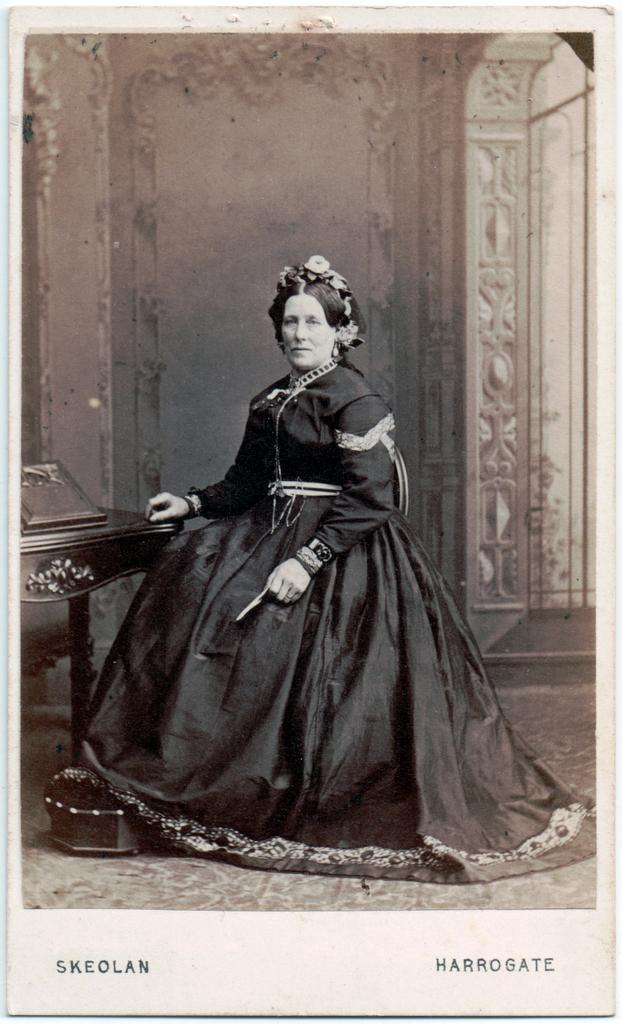Could you give a brief overview of what you see in this image? In the image we can see there is a woman sitting on the chair and behind there is a wall. The image is in black and white colour. 